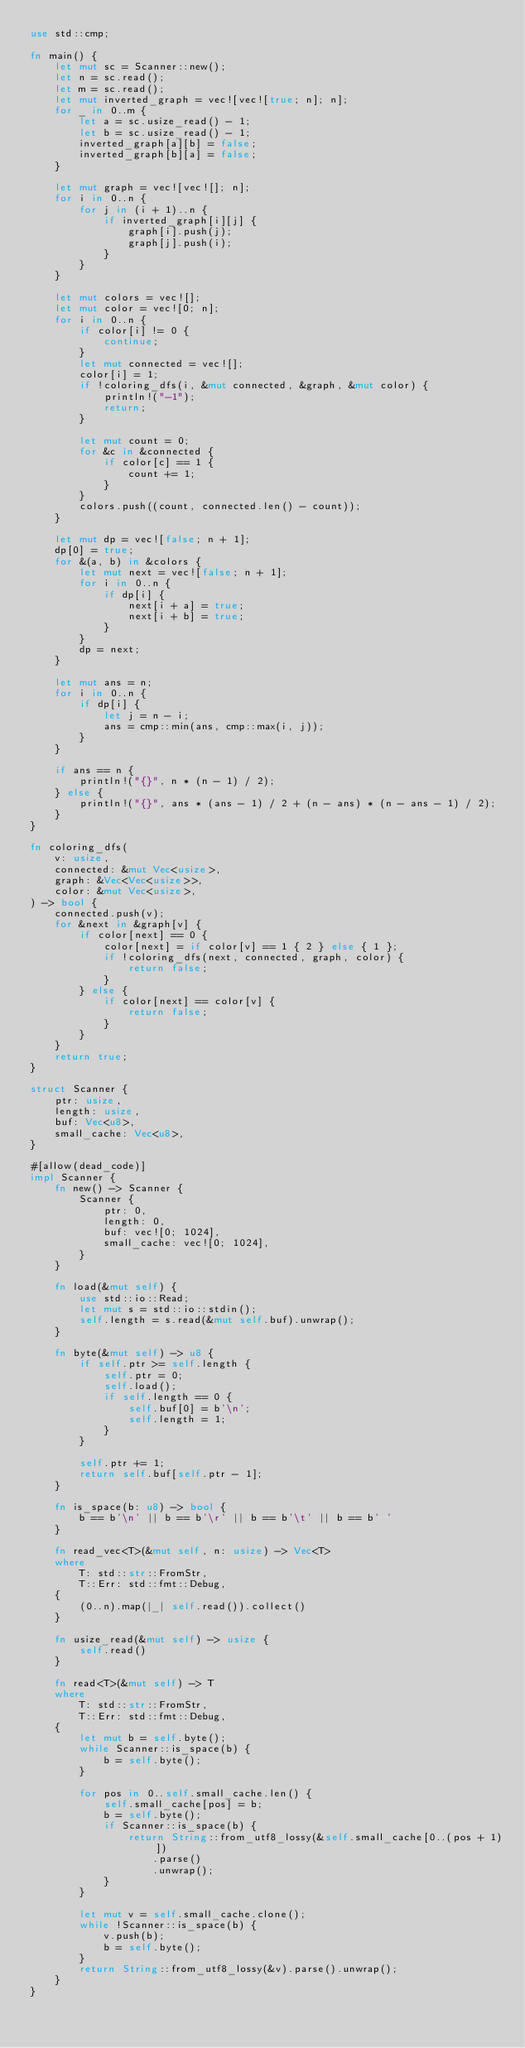Convert code to text. <code><loc_0><loc_0><loc_500><loc_500><_Rust_>use std::cmp;

fn main() {
    let mut sc = Scanner::new();
    let n = sc.read();
    let m = sc.read();
    let mut inverted_graph = vec![vec![true; n]; n];
    for _ in 0..m {
        let a = sc.usize_read() - 1;
        let b = sc.usize_read() - 1;
        inverted_graph[a][b] = false;
        inverted_graph[b][a] = false;
    }

    let mut graph = vec![vec![]; n];
    for i in 0..n {
        for j in (i + 1)..n {
            if inverted_graph[i][j] {
                graph[i].push(j);
                graph[j].push(i);
            }
        }
    }

    let mut colors = vec![];
    let mut color = vec![0; n];
    for i in 0..n {
        if color[i] != 0 {
            continue;
        }
        let mut connected = vec![];
        color[i] = 1;
        if !coloring_dfs(i, &mut connected, &graph, &mut color) {
            println!("-1");
            return;
        }

        let mut count = 0;
        for &c in &connected {
            if color[c] == 1 {
                count += 1;
            }
        }
        colors.push((count, connected.len() - count));
    }

    let mut dp = vec![false; n + 1];
    dp[0] = true;
    for &(a, b) in &colors {
        let mut next = vec![false; n + 1];
        for i in 0..n {
            if dp[i] {
                next[i + a] = true;
                next[i + b] = true;
            }
        }
        dp = next;
    }

    let mut ans = n;
    for i in 0..n {
        if dp[i] {
            let j = n - i;
            ans = cmp::min(ans, cmp::max(i, j));
        }
    }

    if ans == n {
        println!("{}", n * (n - 1) / 2);
    } else {
        println!("{}", ans * (ans - 1) / 2 + (n - ans) * (n - ans - 1) / 2);
    }
}

fn coloring_dfs(
    v: usize,
    connected: &mut Vec<usize>,
    graph: &Vec<Vec<usize>>,
    color: &mut Vec<usize>,
) -> bool {
    connected.push(v);
    for &next in &graph[v] {
        if color[next] == 0 {
            color[next] = if color[v] == 1 { 2 } else { 1 };
            if !coloring_dfs(next, connected, graph, color) {
                return false;
            }
        } else {
            if color[next] == color[v] {
                return false;
            }
        }
    }
    return true;
}

struct Scanner {
    ptr: usize,
    length: usize,
    buf: Vec<u8>,
    small_cache: Vec<u8>,
}

#[allow(dead_code)]
impl Scanner {
    fn new() -> Scanner {
        Scanner {
            ptr: 0,
            length: 0,
            buf: vec![0; 1024],
            small_cache: vec![0; 1024],
        }
    }

    fn load(&mut self) {
        use std::io::Read;
        let mut s = std::io::stdin();
        self.length = s.read(&mut self.buf).unwrap();
    }

    fn byte(&mut self) -> u8 {
        if self.ptr >= self.length {
            self.ptr = 0;
            self.load();
            if self.length == 0 {
                self.buf[0] = b'\n';
                self.length = 1;
            }
        }

        self.ptr += 1;
        return self.buf[self.ptr - 1];
    }

    fn is_space(b: u8) -> bool {
        b == b'\n' || b == b'\r' || b == b'\t' || b == b' '
    }

    fn read_vec<T>(&mut self, n: usize) -> Vec<T>
    where
        T: std::str::FromStr,
        T::Err: std::fmt::Debug,
    {
        (0..n).map(|_| self.read()).collect()
    }

    fn usize_read(&mut self) -> usize {
        self.read()
    }

    fn read<T>(&mut self) -> T
    where
        T: std::str::FromStr,
        T::Err: std::fmt::Debug,
    {
        let mut b = self.byte();
        while Scanner::is_space(b) {
            b = self.byte();
        }

        for pos in 0..self.small_cache.len() {
            self.small_cache[pos] = b;
            b = self.byte();
            if Scanner::is_space(b) {
                return String::from_utf8_lossy(&self.small_cache[0..(pos + 1)])
                    .parse()
                    .unwrap();
            }
        }

        let mut v = self.small_cache.clone();
        while !Scanner::is_space(b) {
            v.push(b);
            b = self.byte();
        }
        return String::from_utf8_lossy(&v).parse().unwrap();
    }
}
</code> 